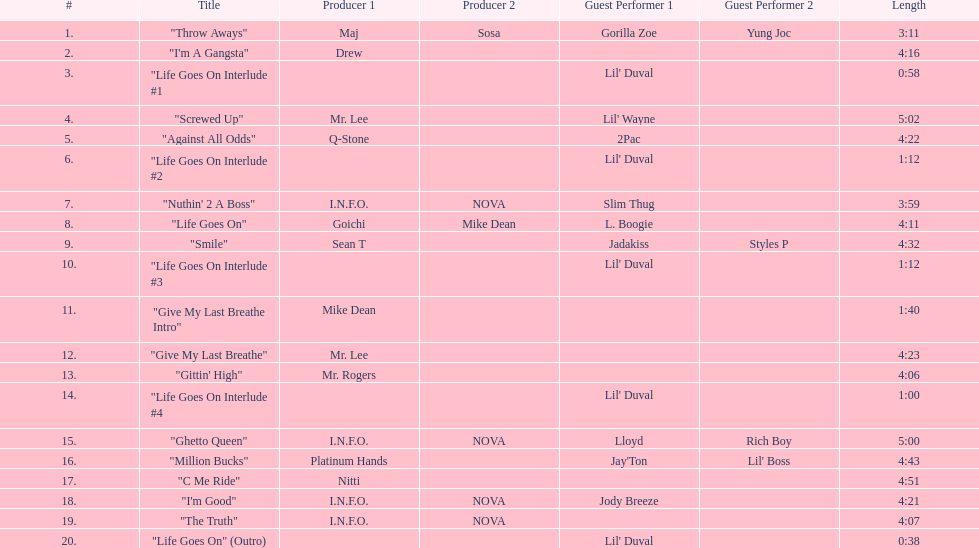What is the last track produced by mr. lee? "Give My Last Breathe". 